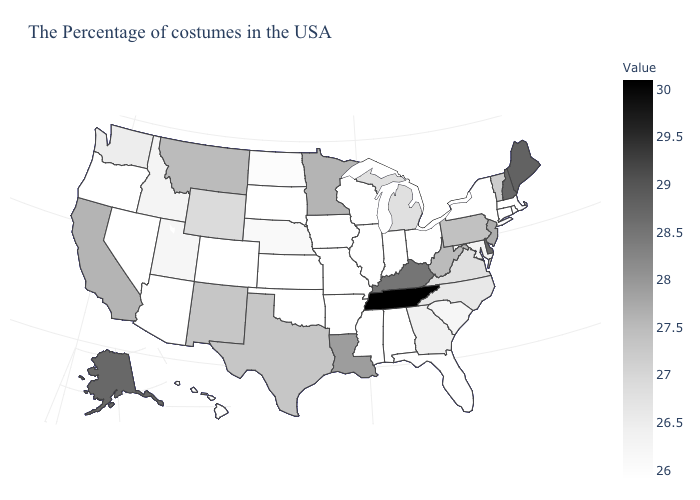Does Michigan have a lower value than Alaska?
Quick response, please. Yes. Which states hav the highest value in the MidWest?
Quick response, please. Minnesota. Among the states that border New York , does New Jersey have the highest value?
Quick response, please. Yes. Does Tennessee have the highest value in the USA?
Short answer required. Yes. Does Maine have the highest value in the Northeast?
Write a very short answer. Yes. Among the states that border Georgia , does Florida have the lowest value?
Answer briefly. Yes. 